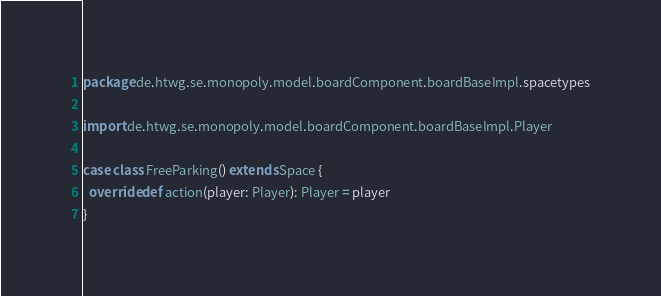Convert code to text. <code><loc_0><loc_0><loc_500><loc_500><_Scala_>package de.htwg.se.monopoly.model.boardComponent.boardBaseImpl.spacetypes

import de.htwg.se.monopoly.model.boardComponent.boardBaseImpl.Player

case class FreeParking() extends Space {
  override def action(player: Player): Player = player
}
</code> 